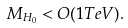Convert formula to latex. <formula><loc_0><loc_0><loc_500><loc_500>M _ { H _ { 0 } } < O ( 1 T e V ) .</formula> 